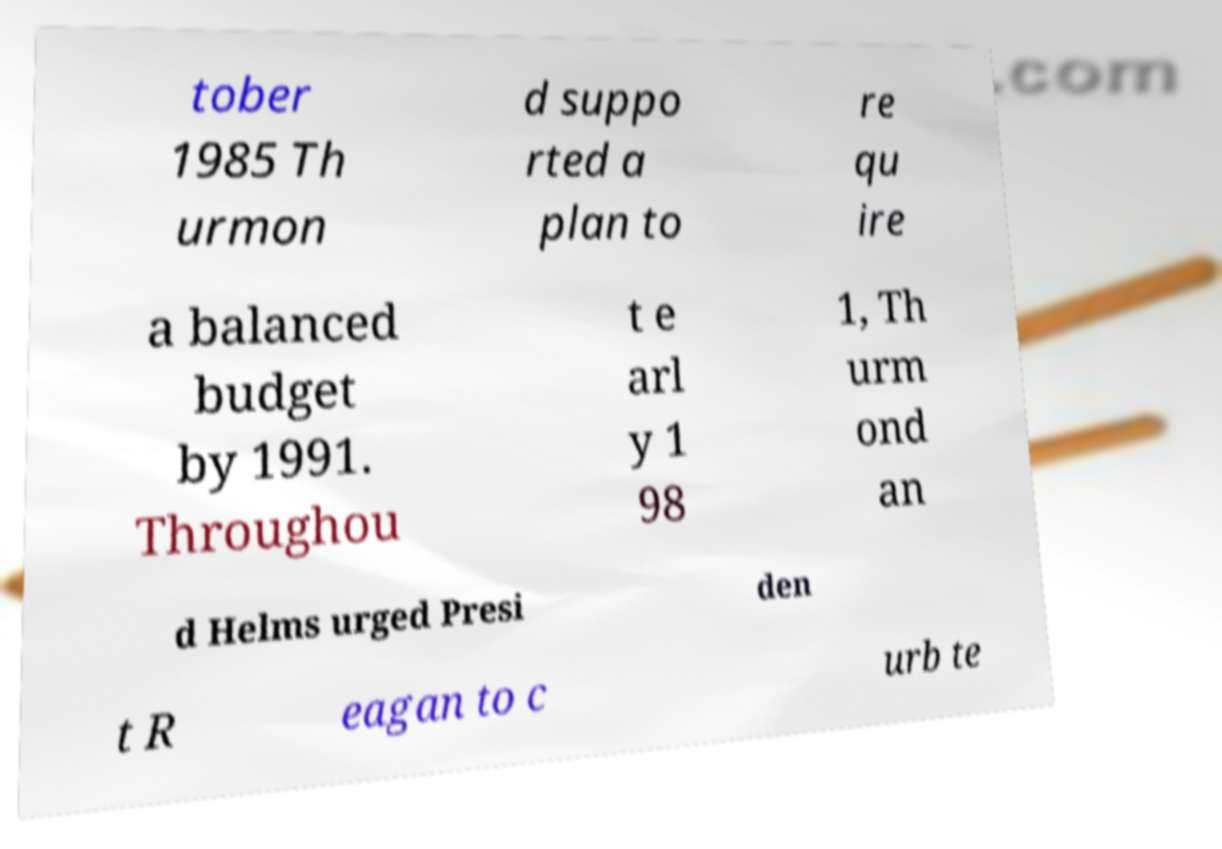Can you read and provide the text displayed in the image?This photo seems to have some interesting text. Can you extract and type it out for me? tober 1985 Th urmon d suppo rted a plan to re qu ire a balanced budget by 1991. Throughou t e arl y 1 98 1, Th urm ond an d Helms urged Presi den t R eagan to c urb te 